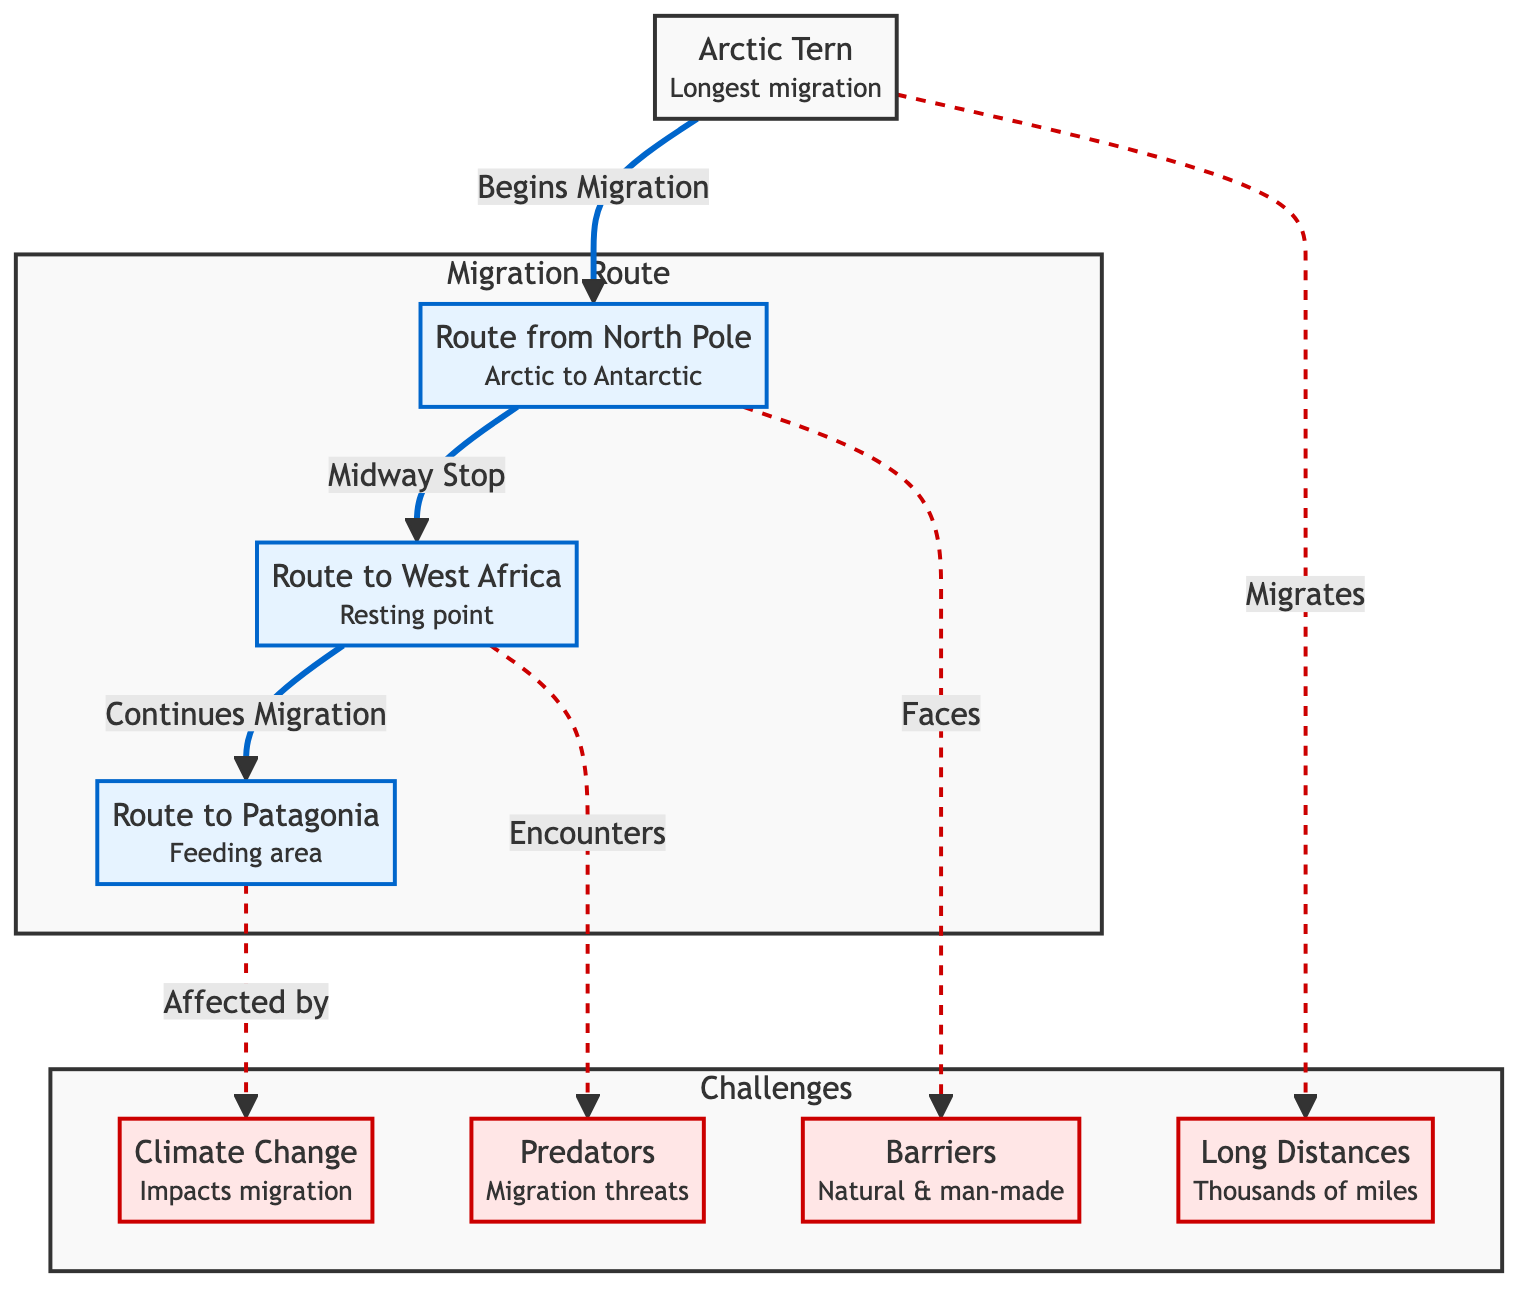What's the longest migration described in the diagram? The diagram identifies the Arctic Tern as the species with the longest migration. By locating the Arctic Tern node, we see the label specifying "Longest migration."
Answer: Arctic Tern How many routes are shown in the migration route? The diagram displays three routes labeled as Route from North Pole, Route to West Africa, and Route to Patagonia. By counting the distinct route nodes, we confirm there are three.
Answer: 3 What obstacles are faced by the Arctic Tern during migration? The diagram lists four obstacles: barriers, long distances, predators, and climate change. These are categorized under the Challenges subgraph.
Answer: Barriers, long distances, predators, climate change Which route is a midway stop for the Arctic Tern's migration? The diagram indicates that the route to West Africa serves as a midway stop, as shown by the label "Midway Stop" connecting Route from North Pole to Route to West Africa.
Answer: Route to West Africa What are the impacts of climate change on the migration? The diagram notes that the Arctic Tern's route to Patagonia is "Affected by" climate change. This indicates a direct impact relationship.
Answer: Affected by climate change Which type of challenges does the Arctic Tern encounter on its migration to West Africa? The diagram highlights "predators" as a challenge encountered during the migration to West Africa, labeling the relationship as "Encounters."
Answer: Predators How does the diagram illustrate the concept of long distances? The Arctic Tern's migration is described as "Long Distances," which is visually represented showing that it migrates thousands of miles, indicated by the dashed line leading to the respective node.
Answer: Long Distances What is the final destination of the Arctic Tern's migration route? The diagram shows that the Arctic Tern migrates to Patagonia as its final destination, with a clear directional flow from the previous routes.
Answer: Patagonia 